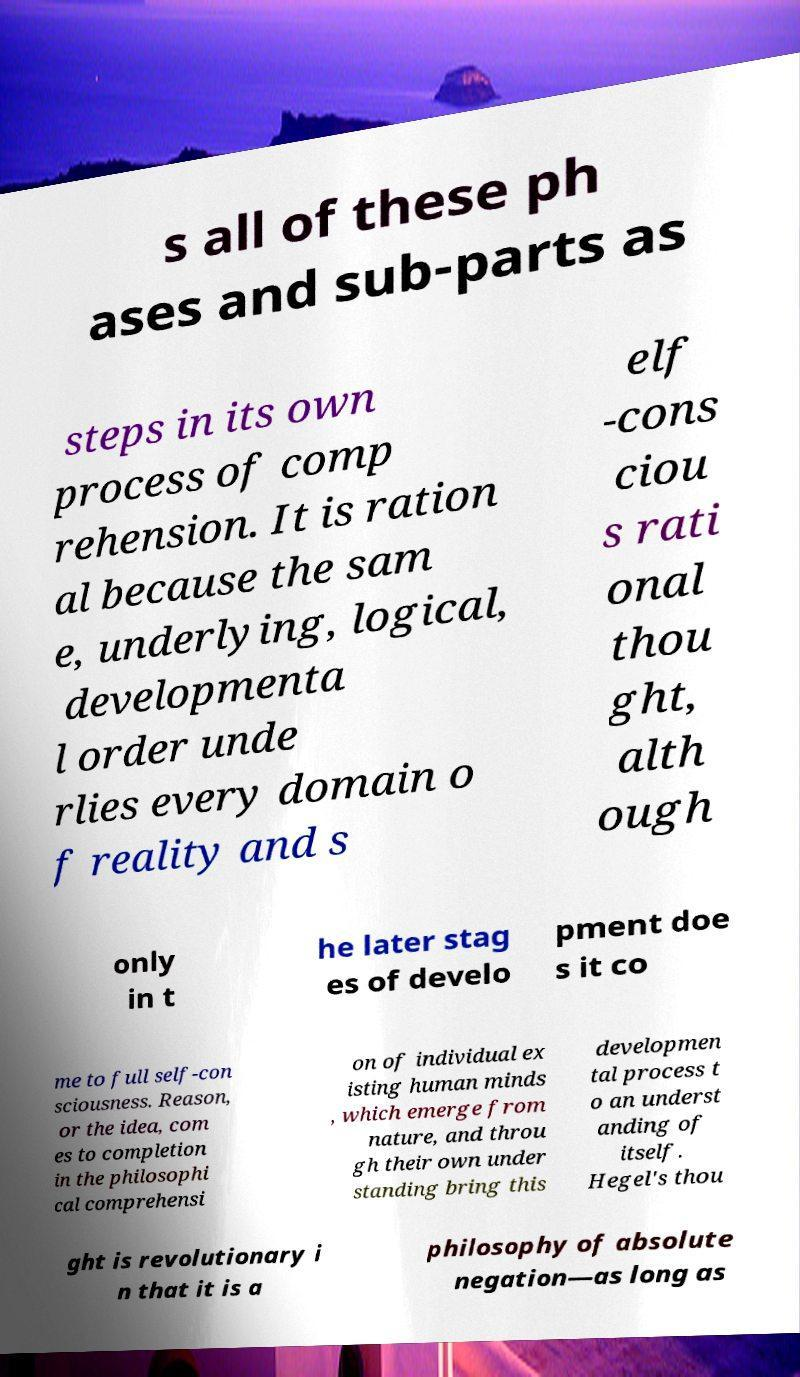I need the written content from this picture converted into text. Can you do that? s all of these ph ases and sub-parts as steps in its own process of comp rehension. It is ration al because the sam e, underlying, logical, developmenta l order unde rlies every domain o f reality and s elf -cons ciou s rati onal thou ght, alth ough only in t he later stag es of develo pment doe s it co me to full self-con sciousness. Reason, or the idea, com es to completion in the philosophi cal comprehensi on of individual ex isting human minds , which emerge from nature, and throu gh their own under standing bring this developmen tal process t o an underst anding of itself. Hegel's thou ght is revolutionary i n that it is a philosophy of absolute negation—as long as 